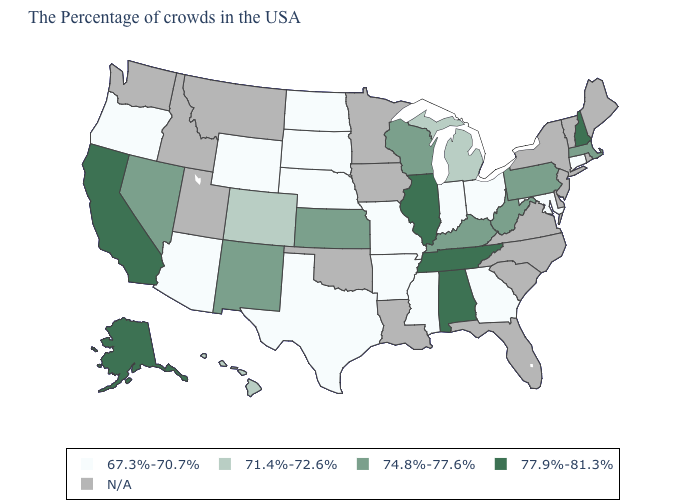How many symbols are there in the legend?
Answer briefly. 5. Which states hav the highest value in the MidWest?
Answer briefly. Illinois. What is the value of Nebraska?
Write a very short answer. 67.3%-70.7%. Name the states that have a value in the range 77.9%-81.3%?
Concise answer only. New Hampshire, Alabama, Tennessee, Illinois, California, Alaska. Among the states that border Texas , does Arkansas have the highest value?
Keep it brief. No. What is the value of Virginia?
Keep it brief. N/A. How many symbols are there in the legend?
Quick response, please. 5. What is the value of Vermont?
Give a very brief answer. N/A. Name the states that have a value in the range 71.4%-72.6%?
Be succinct. Michigan, Colorado, Hawaii. What is the highest value in the Northeast ?
Write a very short answer. 77.9%-81.3%. What is the value of Wisconsin?
Keep it brief. 74.8%-77.6%. Does the first symbol in the legend represent the smallest category?
Give a very brief answer. Yes. What is the lowest value in the MidWest?
Write a very short answer. 67.3%-70.7%. Name the states that have a value in the range 67.3%-70.7%?
Write a very short answer. Connecticut, Maryland, Ohio, Georgia, Indiana, Mississippi, Missouri, Arkansas, Nebraska, Texas, South Dakota, North Dakota, Wyoming, Arizona, Oregon. 